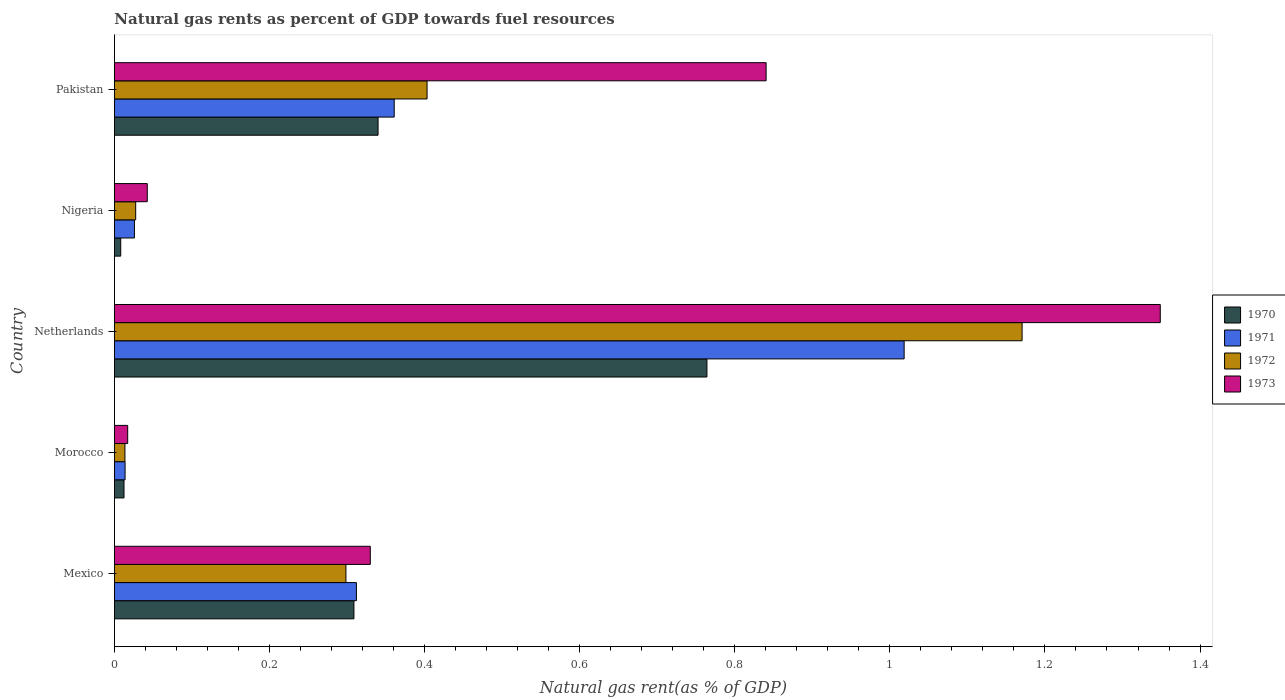How many different coloured bars are there?
Keep it short and to the point. 4. Are the number of bars on each tick of the Y-axis equal?
Offer a terse response. Yes. How many bars are there on the 1st tick from the top?
Provide a succinct answer. 4. How many bars are there on the 5th tick from the bottom?
Your response must be concise. 4. What is the label of the 2nd group of bars from the top?
Ensure brevity in your answer.  Nigeria. What is the natural gas rent in 1970 in Mexico?
Keep it short and to the point. 0.31. Across all countries, what is the maximum natural gas rent in 1970?
Your response must be concise. 0.76. Across all countries, what is the minimum natural gas rent in 1970?
Provide a succinct answer. 0.01. In which country was the natural gas rent in 1973 minimum?
Provide a succinct answer. Morocco. What is the total natural gas rent in 1970 in the graph?
Provide a succinct answer. 1.43. What is the difference between the natural gas rent in 1971 in Morocco and that in Nigeria?
Ensure brevity in your answer.  -0.01. What is the difference between the natural gas rent in 1970 in Morocco and the natural gas rent in 1972 in Nigeria?
Your answer should be compact. -0.02. What is the average natural gas rent in 1972 per country?
Offer a very short reply. 0.38. What is the difference between the natural gas rent in 1973 and natural gas rent in 1971 in Morocco?
Make the answer very short. 0. What is the ratio of the natural gas rent in 1973 in Morocco to that in Nigeria?
Your response must be concise. 0.4. Is the difference between the natural gas rent in 1973 in Netherlands and Pakistan greater than the difference between the natural gas rent in 1971 in Netherlands and Pakistan?
Give a very brief answer. No. What is the difference between the highest and the second highest natural gas rent in 1971?
Your response must be concise. 0.66. What is the difference between the highest and the lowest natural gas rent in 1972?
Your answer should be very brief. 1.16. In how many countries, is the natural gas rent in 1972 greater than the average natural gas rent in 1972 taken over all countries?
Your answer should be very brief. 2. What does the 3rd bar from the bottom in Pakistan represents?
Give a very brief answer. 1972. What is the difference between two consecutive major ticks on the X-axis?
Make the answer very short. 0.2. Where does the legend appear in the graph?
Keep it short and to the point. Center right. How many legend labels are there?
Keep it short and to the point. 4. How are the legend labels stacked?
Your response must be concise. Vertical. What is the title of the graph?
Your response must be concise. Natural gas rents as percent of GDP towards fuel resources. Does "1995" appear as one of the legend labels in the graph?
Your response must be concise. No. What is the label or title of the X-axis?
Make the answer very short. Natural gas rent(as % of GDP). What is the Natural gas rent(as % of GDP) of 1970 in Mexico?
Ensure brevity in your answer.  0.31. What is the Natural gas rent(as % of GDP) in 1971 in Mexico?
Give a very brief answer. 0.31. What is the Natural gas rent(as % of GDP) in 1972 in Mexico?
Make the answer very short. 0.3. What is the Natural gas rent(as % of GDP) of 1973 in Mexico?
Provide a succinct answer. 0.33. What is the Natural gas rent(as % of GDP) in 1970 in Morocco?
Your answer should be compact. 0.01. What is the Natural gas rent(as % of GDP) in 1971 in Morocco?
Offer a terse response. 0.01. What is the Natural gas rent(as % of GDP) in 1972 in Morocco?
Ensure brevity in your answer.  0.01. What is the Natural gas rent(as % of GDP) of 1973 in Morocco?
Offer a very short reply. 0.02. What is the Natural gas rent(as % of GDP) in 1970 in Netherlands?
Give a very brief answer. 0.76. What is the Natural gas rent(as % of GDP) of 1971 in Netherlands?
Keep it short and to the point. 1.02. What is the Natural gas rent(as % of GDP) in 1972 in Netherlands?
Offer a very short reply. 1.17. What is the Natural gas rent(as % of GDP) of 1973 in Netherlands?
Your answer should be very brief. 1.35. What is the Natural gas rent(as % of GDP) of 1970 in Nigeria?
Ensure brevity in your answer.  0.01. What is the Natural gas rent(as % of GDP) in 1971 in Nigeria?
Provide a succinct answer. 0.03. What is the Natural gas rent(as % of GDP) of 1972 in Nigeria?
Make the answer very short. 0.03. What is the Natural gas rent(as % of GDP) of 1973 in Nigeria?
Your answer should be compact. 0.04. What is the Natural gas rent(as % of GDP) of 1970 in Pakistan?
Offer a very short reply. 0.34. What is the Natural gas rent(as % of GDP) of 1971 in Pakistan?
Offer a very short reply. 0.36. What is the Natural gas rent(as % of GDP) in 1972 in Pakistan?
Your answer should be very brief. 0.4. What is the Natural gas rent(as % of GDP) in 1973 in Pakistan?
Provide a short and direct response. 0.84. Across all countries, what is the maximum Natural gas rent(as % of GDP) of 1970?
Your response must be concise. 0.76. Across all countries, what is the maximum Natural gas rent(as % of GDP) of 1971?
Keep it short and to the point. 1.02. Across all countries, what is the maximum Natural gas rent(as % of GDP) of 1972?
Your answer should be compact. 1.17. Across all countries, what is the maximum Natural gas rent(as % of GDP) in 1973?
Keep it short and to the point. 1.35. Across all countries, what is the minimum Natural gas rent(as % of GDP) of 1970?
Offer a very short reply. 0.01. Across all countries, what is the minimum Natural gas rent(as % of GDP) in 1971?
Your response must be concise. 0.01. Across all countries, what is the minimum Natural gas rent(as % of GDP) of 1972?
Your answer should be compact. 0.01. Across all countries, what is the minimum Natural gas rent(as % of GDP) of 1973?
Offer a very short reply. 0.02. What is the total Natural gas rent(as % of GDP) in 1970 in the graph?
Offer a very short reply. 1.43. What is the total Natural gas rent(as % of GDP) of 1971 in the graph?
Make the answer very short. 1.73. What is the total Natural gas rent(as % of GDP) in 1972 in the graph?
Ensure brevity in your answer.  1.91. What is the total Natural gas rent(as % of GDP) in 1973 in the graph?
Make the answer very short. 2.58. What is the difference between the Natural gas rent(as % of GDP) in 1970 in Mexico and that in Morocco?
Keep it short and to the point. 0.3. What is the difference between the Natural gas rent(as % of GDP) of 1971 in Mexico and that in Morocco?
Your response must be concise. 0.3. What is the difference between the Natural gas rent(as % of GDP) of 1972 in Mexico and that in Morocco?
Give a very brief answer. 0.28. What is the difference between the Natural gas rent(as % of GDP) in 1973 in Mexico and that in Morocco?
Ensure brevity in your answer.  0.31. What is the difference between the Natural gas rent(as % of GDP) in 1970 in Mexico and that in Netherlands?
Ensure brevity in your answer.  -0.46. What is the difference between the Natural gas rent(as % of GDP) in 1971 in Mexico and that in Netherlands?
Your answer should be compact. -0.71. What is the difference between the Natural gas rent(as % of GDP) in 1972 in Mexico and that in Netherlands?
Make the answer very short. -0.87. What is the difference between the Natural gas rent(as % of GDP) in 1973 in Mexico and that in Netherlands?
Keep it short and to the point. -1.02. What is the difference between the Natural gas rent(as % of GDP) of 1970 in Mexico and that in Nigeria?
Ensure brevity in your answer.  0.3. What is the difference between the Natural gas rent(as % of GDP) of 1971 in Mexico and that in Nigeria?
Ensure brevity in your answer.  0.29. What is the difference between the Natural gas rent(as % of GDP) of 1972 in Mexico and that in Nigeria?
Offer a terse response. 0.27. What is the difference between the Natural gas rent(as % of GDP) in 1973 in Mexico and that in Nigeria?
Your answer should be compact. 0.29. What is the difference between the Natural gas rent(as % of GDP) of 1970 in Mexico and that in Pakistan?
Keep it short and to the point. -0.03. What is the difference between the Natural gas rent(as % of GDP) in 1971 in Mexico and that in Pakistan?
Provide a succinct answer. -0.05. What is the difference between the Natural gas rent(as % of GDP) of 1972 in Mexico and that in Pakistan?
Offer a terse response. -0.1. What is the difference between the Natural gas rent(as % of GDP) of 1973 in Mexico and that in Pakistan?
Offer a very short reply. -0.51. What is the difference between the Natural gas rent(as % of GDP) of 1970 in Morocco and that in Netherlands?
Provide a succinct answer. -0.75. What is the difference between the Natural gas rent(as % of GDP) in 1971 in Morocco and that in Netherlands?
Provide a succinct answer. -1. What is the difference between the Natural gas rent(as % of GDP) of 1972 in Morocco and that in Netherlands?
Make the answer very short. -1.16. What is the difference between the Natural gas rent(as % of GDP) of 1973 in Morocco and that in Netherlands?
Keep it short and to the point. -1.33. What is the difference between the Natural gas rent(as % of GDP) of 1970 in Morocco and that in Nigeria?
Give a very brief answer. 0. What is the difference between the Natural gas rent(as % of GDP) of 1971 in Morocco and that in Nigeria?
Keep it short and to the point. -0.01. What is the difference between the Natural gas rent(as % of GDP) of 1972 in Morocco and that in Nigeria?
Your answer should be compact. -0.01. What is the difference between the Natural gas rent(as % of GDP) in 1973 in Morocco and that in Nigeria?
Give a very brief answer. -0.03. What is the difference between the Natural gas rent(as % of GDP) in 1970 in Morocco and that in Pakistan?
Offer a terse response. -0.33. What is the difference between the Natural gas rent(as % of GDP) in 1971 in Morocco and that in Pakistan?
Make the answer very short. -0.35. What is the difference between the Natural gas rent(as % of GDP) of 1972 in Morocco and that in Pakistan?
Provide a short and direct response. -0.39. What is the difference between the Natural gas rent(as % of GDP) of 1973 in Morocco and that in Pakistan?
Offer a terse response. -0.82. What is the difference between the Natural gas rent(as % of GDP) of 1970 in Netherlands and that in Nigeria?
Give a very brief answer. 0.76. What is the difference between the Natural gas rent(as % of GDP) in 1972 in Netherlands and that in Nigeria?
Your answer should be compact. 1.14. What is the difference between the Natural gas rent(as % of GDP) of 1973 in Netherlands and that in Nigeria?
Your response must be concise. 1.31. What is the difference between the Natural gas rent(as % of GDP) of 1970 in Netherlands and that in Pakistan?
Provide a succinct answer. 0.42. What is the difference between the Natural gas rent(as % of GDP) of 1971 in Netherlands and that in Pakistan?
Provide a short and direct response. 0.66. What is the difference between the Natural gas rent(as % of GDP) of 1972 in Netherlands and that in Pakistan?
Your answer should be compact. 0.77. What is the difference between the Natural gas rent(as % of GDP) of 1973 in Netherlands and that in Pakistan?
Make the answer very short. 0.51. What is the difference between the Natural gas rent(as % of GDP) of 1970 in Nigeria and that in Pakistan?
Ensure brevity in your answer.  -0.33. What is the difference between the Natural gas rent(as % of GDP) of 1971 in Nigeria and that in Pakistan?
Your answer should be very brief. -0.34. What is the difference between the Natural gas rent(as % of GDP) in 1972 in Nigeria and that in Pakistan?
Your answer should be very brief. -0.38. What is the difference between the Natural gas rent(as % of GDP) in 1973 in Nigeria and that in Pakistan?
Provide a succinct answer. -0.8. What is the difference between the Natural gas rent(as % of GDP) of 1970 in Mexico and the Natural gas rent(as % of GDP) of 1971 in Morocco?
Provide a short and direct response. 0.3. What is the difference between the Natural gas rent(as % of GDP) in 1970 in Mexico and the Natural gas rent(as % of GDP) in 1972 in Morocco?
Provide a short and direct response. 0.3. What is the difference between the Natural gas rent(as % of GDP) in 1970 in Mexico and the Natural gas rent(as % of GDP) in 1973 in Morocco?
Ensure brevity in your answer.  0.29. What is the difference between the Natural gas rent(as % of GDP) in 1971 in Mexico and the Natural gas rent(as % of GDP) in 1972 in Morocco?
Keep it short and to the point. 0.3. What is the difference between the Natural gas rent(as % of GDP) of 1971 in Mexico and the Natural gas rent(as % of GDP) of 1973 in Morocco?
Provide a short and direct response. 0.29. What is the difference between the Natural gas rent(as % of GDP) in 1972 in Mexico and the Natural gas rent(as % of GDP) in 1973 in Morocco?
Give a very brief answer. 0.28. What is the difference between the Natural gas rent(as % of GDP) of 1970 in Mexico and the Natural gas rent(as % of GDP) of 1971 in Netherlands?
Ensure brevity in your answer.  -0.71. What is the difference between the Natural gas rent(as % of GDP) of 1970 in Mexico and the Natural gas rent(as % of GDP) of 1972 in Netherlands?
Your answer should be compact. -0.86. What is the difference between the Natural gas rent(as % of GDP) in 1970 in Mexico and the Natural gas rent(as % of GDP) in 1973 in Netherlands?
Offer a terse response. -1.04. What is the difference between the Natural gas rent(as % of GDP) in 1971 in Mexico and the Natural gas rent(as % of GDP) in 1972 in Netherlands?
Offer a terse response. -0.86. What is the difference between the Natural gas rent(as % of GDP) in 1971 in Mexico and the Natural gas rent(as % of GDP) in 1973 in Netherlands?
Keep it short and to the point. -1.04. What is the difference between the Natural gas rent(as % of GDP) in 1972 in Mexico and the Natural gas rent(as % of GDP) in 1973 in Netherlands?
Give a very brief answer. -1.05. What is the difference between the Natural gas rent(as % of GDP) of 1970 in Mexico and the Natural gas rent(as % of GDP) of 1971 in Nigeria?
Make the answer very short. 0.28. What is the difference between the Natural gas rent(as % of GDP) of 1970 in Mexico and the Natural gas rent(as % of GDP) of 1972 in Nigeria?
Make the answer very short. 0.28. What is the difference between the Natural gas rent(as % of GDP) of 1970 in Mexico and the Natural gas rent(as % of GDP) of 1973 in Nigeria?
Give a very brief answer. 0.27. What is the difference between the Natural gas rent(as % of GDP) of 1971 in Mexico and the Natural gas rent(as % of GDP) of 1972 in Nigeria?
Provide a succinct answer. 0.28. What is the difference between the Natural gas rent(as % of GDP) of 1971 in Mexico and the Natural gas rent(as % of GDP) of 1973 in Nigeria?
Provide a succinct answer. 0.27. What is the difference between the Natural gas rent(as % of GDP) of 1972 in Mexico and the Natural gas rent(as % of GDP) of 1973 in Nigeria?
Your answer should be compact. 0.26. What is the difference between the Natural gas rent(as % of GDP) of 1970 in Mexico and the Natural gas rent(as % of GDP) of 1971 in Pakistan?
Give a very brief answer. -0.05. What is the difference between the Natural gas rent(as % of GDP) in 1970 in Mexico and the Natural gas rent(as % of GDP) in 1972 in Pakistan?
Your answer should be compact. -0.09. What is the difference between the Natural gas rent(as % of GDP) of 1970 in Mexico and the Natural gas rent(as % of GDP) of 1973 in Pakistan?
Ensure brevity in your answer.  -0.53. What is the difference between the Natural gas rent(as % of GDP) of 1971 in Mexico and the Natural gas rent(as % of GDP) of 1972 in Pakistan?
Your answer should be very brief. -0.09. What is the difference between the Natural gas rent(as % of GDP) of 1971 in Mexico and the Natural gas rent(as % of GDP) of 1973 in Pakistan?
Your response must be concise. -0.53. What is the difference between the Natural gas rent(as % of GDP) of 1972 in Mexico and the Natural gas rent(as % of GDP) of 1973 in Pakistan?
Provide a short and direct response. -0.54. What is the difference between the Natural gas rent(as % of GDP) of 1970 in Morocco and the Natural gas rent(as % of GDP) of 1971 in Netherlands?
Ensure brevity in your answer.  -1.01. What is the difference between the Natural gas rent(as % of GDP) in 1970 in Morocco and the Natural gas rent(as % of GDP) in 1972 in Netherlands?
Keep it short and to the point. -1.16. What is the difference between the Natural gas rent(as % of GDP) of 1970 in Morocco and the Natural gas rent(as % of GDP) of 1973 in Netherlands?
Ensure brevity in your answer.  -1.34. What is the difference between the Natural gas rent(as % of GDP) of 1971 in Morocco and the Natural gas rent(as % of GDP) of 1972 in Netherlands?
Your answer should be very brief. -1.16. What is the difference between the Natural gas rent(as % of GDP) of 1971 in Morocco and the Natural gas rent(as % of GDP) of 1973 in Netherlands?
Keep it short and to the point. -1.33. What is the difference between the Natural gas rent(as % of GDP) of 1972 in Morocco and the Natural gas rent(as % of GDP) of 1973 in Netherlands?
Provide a succinct answer. -1.34. What is the difference between the Natural gas rent(as % of GDP) in 1970 in Morocco and the Natural gas rent(as % of GDP) in 1971 in Nigeria?
Keep it short and to the point. -0.01. What is the difference between the Natural gas rent(as % of GDP) in 1970 in Morocco and the Natural gas rent(as % of GDP) in 1972 in Nigeria?
Your response must be concise. -0.02. What is the difference between the Natural gas rent(as % of GDP) in 1970 in Morocco and the Natural gas rent(as % of GDP) in 1973 in Nigeria?
Provide a succinct answer. -0.03. What is the difference between the Natural gas rent(as % of GDP) in 1971 in Morocco and the Natural gas rent(as % of GDP) in 1972 in Nigeria?
Provide a short and direct response. -0.01. What is the difference between the Natural gas rent(as % of GDP) in 1971 in Morocco and the Natural gas rent(as % of GDP) in 1973 in Nigeria?
Keep it short and to the point. -0.03. What is the difference between the Natural gas rent(as % of GDP) in 1972 in Morocco and the Natural gas rent(as % of GDP) in 1973 in Nigeria?
Keep it short and to the point. -0.03. What is the difference between the Natural gas rent(as % of GDP) of 1970 in Morocco and the Natural gas rent(as % of GDP) of 1971 in Pakistan?
Make the answer very short. -0.35. What is the difference between the Natural gas rent(as % of GDP) in 1970 in Morocco and the Natural gas rent(as % of GDP) in 1972 in Pakistan?
Your response must be concise. -0.39. What is the difference between the Natural gas rent(as % of GDP) in 1970 in Morocco and the Natural gas rent(as % of GDP) in 1973 in Pakistan?
Offer a terse response. -0.83. What is the difference between the Natural gas rent(as % of GDP) in 1971 in Morocco and the Natural gas rent(as % of GDP) in 1972 in Pakistan?
Your response must be concise. -0.39. What is the difference between the Natural gas rent(as % of GDP) in 1971 in Morocco and the Natural gas rent(as % of GDP) in 1973 in Pakistan?
Keep it short and to the point. -0.83. What is the difference between the Natural gas rent(as % of GDP) of 1972 in Morocco and the Natural gas rent(as % of GDP) of 1973 in Pakistan?
Your answer should be very brief. -0.83. What is the difference between the Natural gas rent(as % of GDP) of 1970 in Netherlands and the Natural gas rent(as % of GDP) of 1971 in Nigeria?
Provide a succinct answer. 0.74. What is the difference between the Natural gas rent(as % of GDP) of 1970 in Netherlands and the Natural gas rent(as % of GDP) of 1972 in Nigeria?
Your answer should be very brief. 0.74. What is the difference between the Natural gas rent(as % of GDP) in 1970 in Netherlands and the Natural gas rent(as % of GDP) in 1973 in Nigeria?
Provide a short and direct response. 0.72. What is the difference between the Natural gas rent(as % of GDP) in 1971 in Netherlands and the Natural gas rent(as % of GDP) in 1972 in Nigeria?
Give a very brief answer. 0.99. What is the difference between the Natural gas rent(as % of GDP) of 1971 in Netherlands and the Natural gas rent(as % of GDP) of 1973 in Nigeria?
Give a very brief answer. 0.98. What is the difference between the Natural gas rent(as % of GDP) of 1972 in Netherlands and the Natural gas rent(as % of GDP) of 1973 in Nigeria?
Your answer should be compact. 1.13. What is the difference between the Natural gas rent(as % of GDP) in 1970 in Netherlands and the Natural gas rent(as % of GDP) in 1971 in Pakistan?
Keep it short and to the point. 0.4. What is the difference between the Natural gas rent(as % of GDP) in 1970 in Netherlands and the Natural gas rent(as % of GDP) in 1972 in Pakistan?
Your response must be concise. 0.36. What is the difference between the Natural gas rent(as % of GDP) of 1970 in Netherlands and the Natural gas rent(as % of GDP) of 1973 in Pakistan?
Your response must be concise. -0.08. What is the difference between the Natural gas rent(as % of GDP) in 1971 in Netherlands and the Natural gas rent(as % of GDP) in 1972 in Pakistan?
Make the answer very short. 0.62. What is the difference between the Natural gas rent(as % of GDP) of 1971 in Netherlands and the Natural gas rent(as % of GDP) of 1973 in Pakistan?
Make the answer very short. 0.18. What is the difference between the Natural gas rent(as % of GDP) of 1972 in Netherlands and the Natural gas rent(as % of GDP) of 1973 in Pakistan?
Keep it short and to the point. 0.33. What is the difference between the Natural gas rent(as % of GDP) in 1970 in Nigeria and the Natural gas rent(as % of GDP) in 1971 in Pakistan?
Make the answer very short. -0.35. What is the difference between the Natural gas rent(as % of GDP) of 1970 in Nigeria and the Natural gas rent(as % of GDP) of 1972 in Pakistan?
Provide a short and direct response. -0.4. What is the difference between the Natural gas rent(as % of GDP) in 1970 in Nigeria and the Natural gas rent(as % of GDP) in 1973 in Pakistan?
Provide a succinct answer. -0.83. What is the difference between the Natural gas rent(as % of GDP) of 1971 in Nigeria and the Natural gas rent(as % of GDP) of 1972 in Pakistan?
Offer a very short reply. -0.38. What is the difference between the Natural gas rent(as % of GDP) in 1971 in Nigeria and the Natural gas rent(as % of GDP) in 1973 in Pakistan?
Offer a terse response. -0.81. What is the difference between the Natural gas rent(as % of GDP) of 1972 in Nigeria and the Natural gas rent(as % of GDP) of 1973 in Pakistan?
Provide a short and direct response. -0.81. What is the average Natural gas rent(as % of GDP) of 1970 per country?
Offer a very short reply. 0.29. What is the average Natural gas rent(as % of GDP) in 1971 per country?
Give a very brief answer. 0.35. What is the average Natural gas rent(as % of GDP) in 1972 per country?
Your response must be concise. 0.38. What is the average Natural gas rent(as % of GDP) of 1973 per country?
Your response must be concise. 0.52. What is the difference between the Natural gas rent(as % of GDP) of 1970 and Natural gas rent(as % of GDP) of 1971 in Mexico?
Give a very brief answer. -0. What is the difference between the Natural gas rent(as % of GDP) in 1970 and Natural gas rent(as % of GDP) in 1972 in Mexico?
Make the answer very short. 0.01. What is the difference between the Natural gas rent(as % of GDP) of 1970 and Natural gas rent(as % of GDP) of 1973 in Mexico?
Give a very brief answer. -0.02. What is the difference between the Natural gas rent(as % of GDP) in 1971 and Natural gas rent(as % of GDP) in 1972 in Mexico?
Your answer should be very brief. 0.01. What is the difference between the Natural gas rent(as % of GDP) in 1971 and Natural gas rent(as % of GDP) in 1973 in Mexico?
Provide a succinct answer. -0.02. What is the difference between the Natural gas rent(as % of GDP) in 1972 and Natural gas rent(as % of GDP) in 1973 in Mexico?
Provide a succinct answer. -0.03. What is the difference between the Natural gas rent(as % of GDP) in 1970 and Natural gas rent(as % of GDP) in 1971 in Morocco?
Keep it short and to the point. -0. What is the difference between the Natural gas rent(as % of GDP) of 1970 and Natural gas rent(as % of GDP) of 1972 in Morocco?
Keep it short and to the point. -0. What is the difference between the Natural gas rent(as % of GDP) in 1970 and Natural gas rent(as % of GDP) in 1973 in Morocco?
Give a very brief answer. -0. What is the difference between the Natural gas rent(as % of GDP) in 1971 and Natural gas rent(as % of GDP) in 1973 in Morocco?
Provide a short and direct response. -0. What is the difference between the Natural gas rent(as % of GDP) in 1972 and Natural gas rent(as % of GDP) in 1973 in Morocco?
Your response must be concise. -0. What is the difference between the Natural gas rent(as % of GDP) of 1970 and Natural gas rent(as % of GDP) of 1971 in Netherlands?
Give a very brief answer. -0.25. What is the difference between the Natural gas rent(as % of GDP) of 1970 and Natural gas rent(as % of GDP) of 1972 in Netherlands?
Ensure brevity in your answer.  -0.41. What is the difference between the Natural gas rent(as % of GDP) of 1970 and Natural gas rent(as % of GDP) of 1973 in Netherlands?
Ensure brevity in your answer.  -0.58. What is the difference between the Natural gas rent(as % of GDP) in 1971 and Natural gas rent(as % of GDP) in 1972 in Netherlands?
Your answer should be compact. -0.15. What is the difference between the Natural gas rent(as % of GDP) of 1971 and Natural gas rent(as % of GDP) of 1973 in Netherlands?
Provide a short and direct response. -0.33. What is the difference between the Natural gas rent(as % of GDP) of 1972 and Natural gas rent(as % of GDP) of 1973 in Netherlands?
Provide a succinct answer. -0.18. What is the difference between the Natural gas rent(as % of GDP) of 1970 and Natural gas rent(as % of GDP) of 1971 in Nigeria?
Offer a very short reply. -0.02. What is the difference between the Natural gas rent(as % of GDP) in 1970 and Natural gas rent(as % of GDP) in 1972 in Nigeria?
Offer a terse response. -0.02. What is the difference between the Natural gas rent(as % of GDP) of 1970 and Natural gas rent(as % of GDP) of 1973 in Nigeria?
Your response must be concise. -0.03. What is the difference between the Natural gas rent(as % of GDP) of 1971 and Natural gas rent(as % of GDP) of 1972 in Nigeria?
Offer a very short reply. -0. What is the difference between the Natural gas rent(as % of GDP) of 1971 and Natural gas rent(as % of GDP) of 1973 in Nigeria?
Provide a short and direct response. -0.02. What is the difference between the Natural gas rent(as % of GDP) in 1972 and Natural gas rent(as % of GDP) in 1973 in Nigeria?
Offer a terse response. -0.01. What is the difference between the Natural gas rent(as % of GDP) of 1970 and Natural gas rent(as % of GDP) of 1971 in Pakistan?
Offer a terse response. -0.02. What is the difference between the Natural gas rent(as % of GDP) in 1970 and Natural gas rent(as % of GDP) in 1972 in Pakistan?
Ensure brevity in your answer.  -0.06. What is the difference between the Natural gas rent(as % of GDP) in 1970 and Natural gas rent(as % of GDP) in 1973 in Pakistan?
Provide a succinct answer. -0.5. What is the difference between the Natural gas rent(as % of GDP) in 1971 and Natural gas rent(as % of GDP) in 1972 in Pakistan?
Offer a terse response. -0.04. What is the difference between the Natural gas rent(as % of GDP) of 1971 and Natural gas rent(as % of GDP) of 1973 in Pakistan?
Keep it short and to the point. -0.48. What is the difference between the Natural gas rent(as % of GDP) in 1972 and Natural gas rent(as % of GDP) in 1973 in Pakistan?
Ensure brevity in your answer.  -0.44. What is the ratio of the Natural gas rent(as % of GDP) in 1970 in Mexico to that in Morocco?
Your answer should be very brief. 25. What is the ratio of the Natural gas rent(as % of GDP) in 1971 in Mexico to that in Morocco?
Keep it short and to the point. 22.74. What is the ratio of the Natural gas rent(as % of GDP) in 1972 in Mexico to that in Morocco?
Offer a terse response. 22.04. What is the ratio of the Natural gas rent(as % of GDP) in 1973 in Mexico to that in Morocco?
Provide a short and direct response. 19.3. What is the ratio of the Natural gas rent(as % of GDP) in 1970 in Mexico to that in Netherlands?
Keep it short and to the point. 0.4. What is the ratio of the Natural gas rent(as % of GDP) of 1971 in Mexico to that in Netherlands?
Your answer should be compact. 0.31. What is the ratio of the Natural gas rent(as % of GDP) of 1972 in Mexico to that in Netherlands?
Give a very brief answer. 0.26. What is the ratio of the Natural gas rent(as % of GDP) in 1973 in Mexico to that in Netherlands?
Offer a very short reply. 0.24. What is the ratio of the Natural gas rent(as % of GDP) in 1970 in Mexico to that in Nigeria?
Give a very brief answer. 37.97. What is the ratio of the Natural gas rent(as % of GDP) of 1971 in Mexico to that in Nigeria?
Make the answer very short. 12.1. What is the ratio of the Natural gas rent(as % of GDP) of 1972 in Mexico to that in Nigeria?
Provide a short and direct response. 10.89. What is the ratio of the Natural gas rent(as % of GDP) of 1973 in Mexico to that in Nigeria?
Offer a very short reply. 7.79. What is the ratio of the Natural gas rent(as % of GDP) in 1970 in Mexico to that in Pakistan?
Provide a short and direct response. 0.91. What is the ratio of the Natural gas rent(as % of GDP) of 1971 in Mexico to that in Pakistan?
Ensure brevity in your answer.  0.86. What is the ratio of the Natural gas rent(as % of GDP) of 1972 in Mexico to that in Pakistan?
Keep it short and to the point. 0.74. What is the ratio of the Natural gas rent(as % of GDP) of 1973 in Mexico to that in Pakistan?
Give a very brief answer. 0.39. What is the ratio of the Natural gas rent(as % of GDP) of 1970 in Morocco to that in Netherlands?
Your answer should be compact. 0.02. What is the ratio of the Natural gas rent(as % of GDP) in 1971 in Morocco to that in Netherlands?
Ensure brevity in your answer.  0.01. What is the ratio of the Natural gas rent(as % of GDP) of 1972 in Morocco to that in Netherlands?
Your answer should be compact. 0.01. What is the ratio of the Natural gas rent(as % of GDP) in 1973 in Morocco to that in Netherlands?
Your response must be concise. 0.01. What is the ratio of the Natural gas rent(as % of GDP) in 1970 in Morocco to that in Nigeria?
Ensure brevity in your answer.  1.52. What is the ratio of the Natural gas rent(as % of GDP) in 1971 in Morocco to that in Nigeria?
Provide a succinct answer. 0.53. What is the ratio of the Natural gas rent(as % of GDP) of 1972 in Morocco to that in Nigeria?
Make the answer very short. 0.49. What is the ratio of the Natural gas rent(as % of GDP) in 1973 in Morocco to that in Nigeria?
Ensure brevity in your answer.  0.4. What is the ratio of the Natural gas rent(as % of GDP) of 1970 in Morocco to that in Pakistan?
Make the answer very short. 0.04. What is the ratio of the Natural gas rent(as % of GDP) of 1971 in Morocco to that in Pakistan?
Give a very brief answer. 0.04. What is the ratio of the Natural gas rent(as % of GDP) in 1972 in Morocco to that in Pakistan?
Give a very brief answer. 0.03. What is the ratio of the Natural gas rent(as % of GDP) in 1973 in Morocco to that in Pakistan?
Give a very brief answer. 0.02. What is the ratio of the Natural gas rent(as % of GDP) in 1970 in Netherlands to that in Nigeria?
Offer a very short reply. 93.94. What is the ratio of the Natural gas rent(as % of GDP) in 1971 in Netherlands to that in Nigeria?
Your response must be concise. 39.48. What is the ratio of the Natural gas rent(as % of GDP) of 1972 in Netherlands to that in Nigeria?
Provide a succinct answer. 42.7. What is the ratio of the Natural gas rent(as % of GDP) in 1973 in Netherlands to that in Nigeria?
Your response must be concise. 31.84. What is the ratio of the Natural gas rent(as % of GDP) in 1970 in Netherlands to that in Pakistan?
Your answer should be compact. 2.25. What is the ratio of the Natural gas rent(as % of GDP) in 1971 in Netherlands to that in Pakistan?
Offer a very short reply. 2.82. What is the ratio of the Natural gas rent(as % of GDP) in 1972 in Netherlands to that in Pakistan?
Your answer should be compact. 2.9. What is the ratio of the Natural gas rent(as % of GDP) in 1973 in Netherlands to that in Pakistan?
Make the answer very short. 1.6. What is the ratio of the Natural gas rent(as % of GDP) of 1970 in Nigeria to that in Pakistan?
Your response must be concise. 0.02. What is the ratio of the Natural gas rent(as % of GDP) of 1971 in Nigeria to that in Pakistan?
Provide a succinct answer. 0.07. What is the ratio of the Natural gas rent(as % of GDP) in 1972 in Nigeria to that in Pakistan?
Offer a very short reply. 0.07. What is the ratio of the Natural gas rent(as % of GDP) in 1973 in Nigeria to that in Pakistan?
Offer a terse response. 0.05. What is the difference between the highest and the second highest Natural gas rent(as % of GDP) of 1970?
Your answer should be compact. 0.42. What is the difference between the highest and the second highest Natural gas rent(as % of GDP) in 1971?
Offer a terse response. 0.66. What is the difference between the highest and the second highest Natural gas rent(as % of GDP) of 1972?
Your response must be concise. 0.77. What is the difference between the highest and the second highest Natural gas rent(as % of GDP) in 1973?
Provide a short and direct response. 0.51. What is the difference between the highest and the lowest Natural gas rent(as % of GDP) of 1970?
Give a very brief answer. 0.76. What is the difference between the highest and the lowest Natural gas rent(as % of GDP) of 1971?
Your answer should be very brief. 1. What is the difference between the highest and the lowest Natural gas rent(as % of GDP) of 1972?
Keep it short and to the point. 1.16. What is the difference between the highest and the lowest Natural gas rent(as % of GDP) of 1973?
Offer a very short reply. 1.33. 